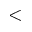<formula> <loc_0><loc_0><loc_500><loc_500><</formula> 